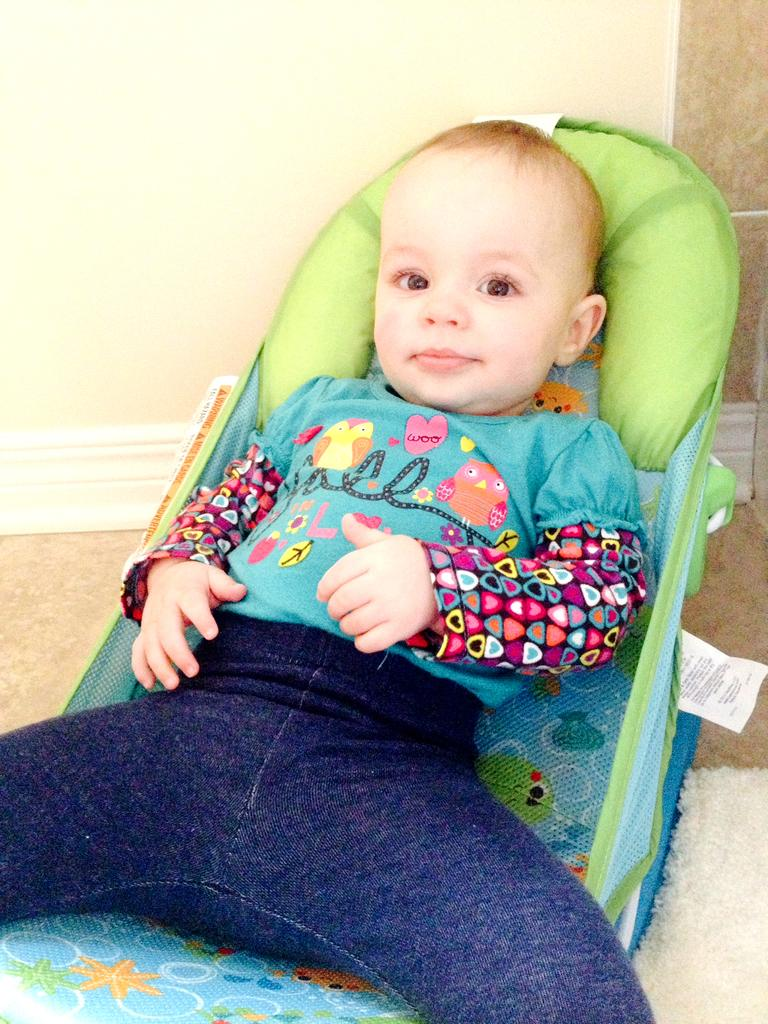What is the main subject of the image? The main subject of the image is a kid. What is the kid sitting on in the image? The kid is sitting on a stroller. Is there any text visible in the image? Yes, there is a label with text on the stroller. What can be seen in the background of the image? There is a wall visible in the background of the image. What type of truck is parked next to the kid in the image? There is no truck present in the image; the kid is sitting on a stroller. Can you tell me the name of the aunt who is pushing the stroller in the image? There is no aunt present in the image, and the stroller is not being pushed by anyone. 